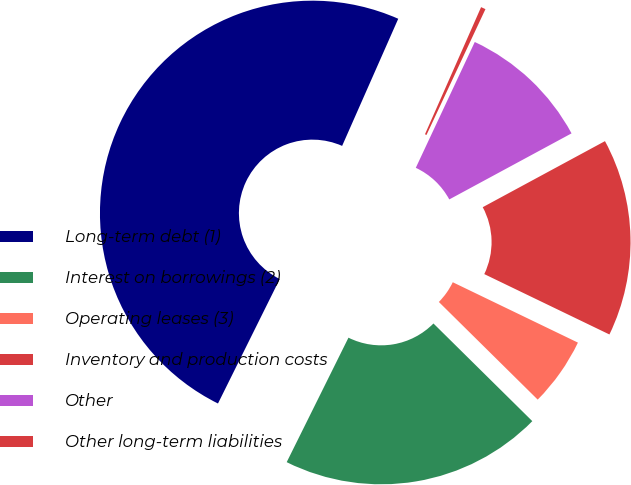<chart> <loc_0><loc_0><loc_500><loc_500><pie_chart><fcel>Long-term debt (1)<fcel>Interest on borrowings (2)<fcel>Operating leases (3)<fcel>Inventory and production costs<fcel>Other<fcel>Other long-term liabilities<nl><fcel>49.29%<fcel>19.93%<fcel>5.25%<fcel>15.04%<fcel>10.14%<fcel>0.36%<nl></chart> 